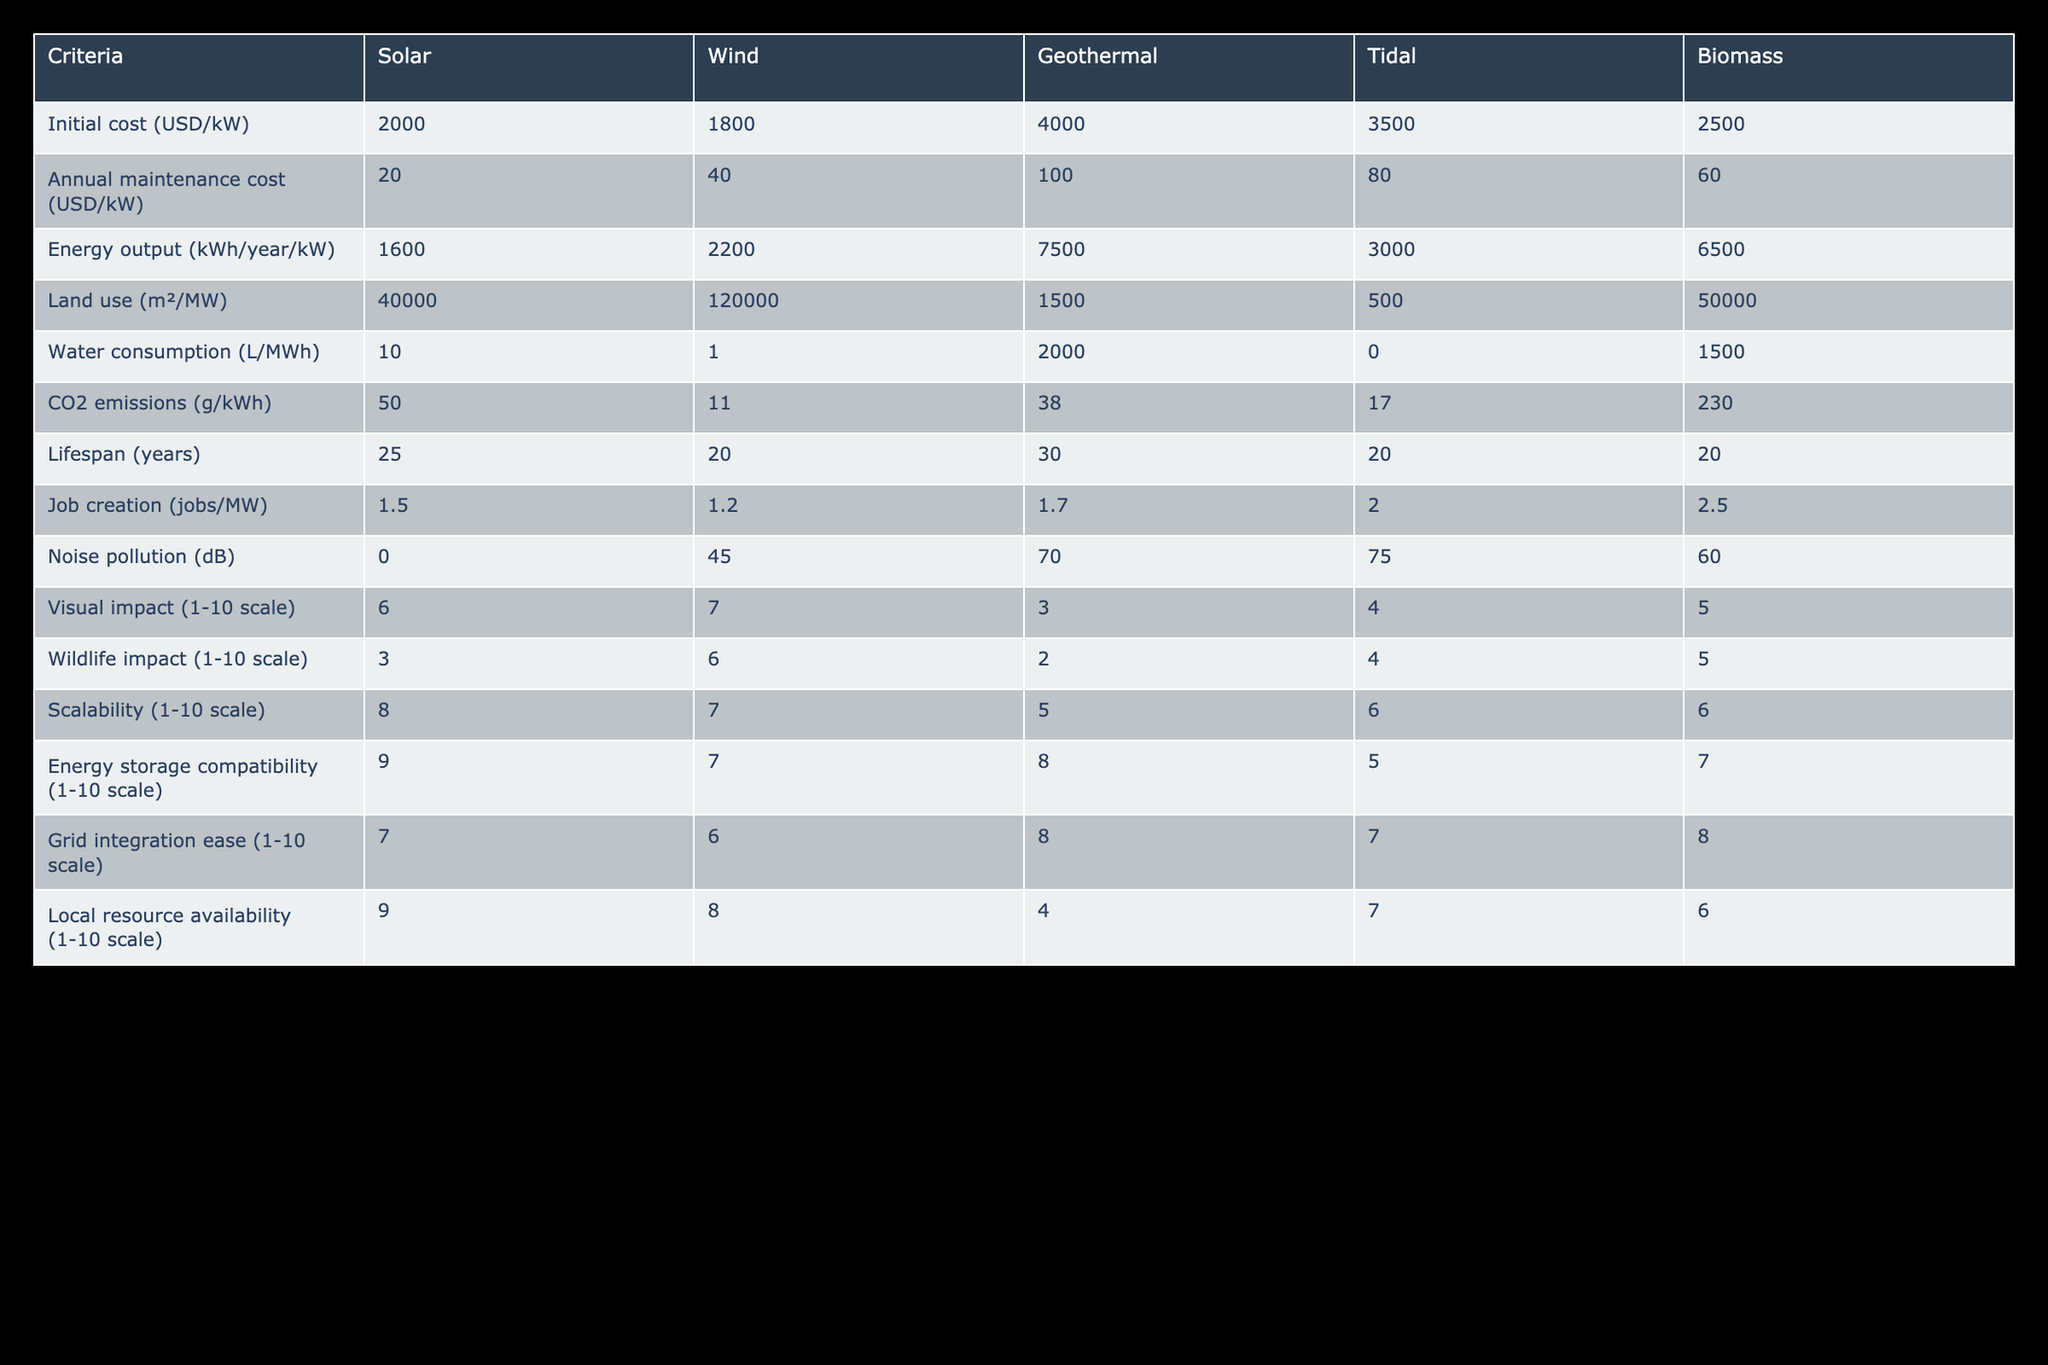What is the initial cost of the wind energy source? The table lists the initial cost of wind energy as 1800 USD/kW.
Answer: 1800 USD/kW Which energy source has the highest energy output per year? According to the table, geothermal energy has the highest output with 7500 kWh/year/kW.
Answer: Geothermal How does the CO2 emission of biomass compare to that of solar energy? The table shows that biomass emits 230 g/kWh while solar emissions are 50 g/kWh, indicating biomass is worse for emissions.
Answer: Biomass has higher CO2 emissions than solar What is the average annual maintenance cost for solar and biomass energy sources? The annual maintenance cost for solar is 20 USD/kW and for biomass it's 60 USD/kW. The average is (20 + 60) / 2 = 40 USD/kW.
Answer: 40 USD/kW Is the water consumption for tidal energy zero? The table states that tidal energy has 0 L/MWh for water consumption. Therefore, it confirms there is no water consumption.
Answer: Yes Which energy source has the lowest land use per megawatt? By examining the land use values, geothermal has 1500 m²/MW, which is the lowest compared to other sources.
Answer: Geothermal What is the total job creation for a wind and solar project of 5 MW each? For wind, with 1.2 jobs/MW, total jobs = 1.2 x 5 = 6 jobs. For solar, with 1.5 jobs/MW, total jobs = 1.5 x 5 = 7.5 jobs. Total for both is 6 + 7.5 = 13.5 jobs.
Answer: 13.5 jobs Which energy source appears to have the highest wildlife impact? From the wildlife impact scale, biomass shows a score of 5, which is higher than others (solar = 3, wind = 6, geothermal = 2, tidal = 4), thus indicating a slightly higher impact.
Answer: Wind (6) What is the lifespan difference between geothermal and wind energy sources? Geothermal energy has a lifespan of 30 years while wind energy has 20 years, resulting in a difference of 30 - 20 = 10 years.
Answer: 10 years 